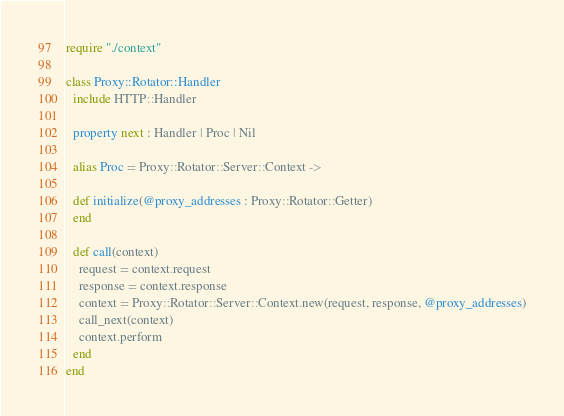<code> <loc_0><loc_0><loc_500><loc_500><_Crystal_>require "./context"

class Proxy::Rotator::Handler
  include HTTP::Handler

  property next : Handler | Proc | Nil

  alias Proc = Proxy::Rotator::Server::Context ->

  def initialize(@proxy_addresses : Proxy::Rotator::Getter)
  end

  def call(context)
    request = context.request
    response = context.response
    context = Proxy::Rotator::Server::Context.new(request, response, @proxy_addresses)
    call_next(context)
    context.perform
  end
end
</code> 